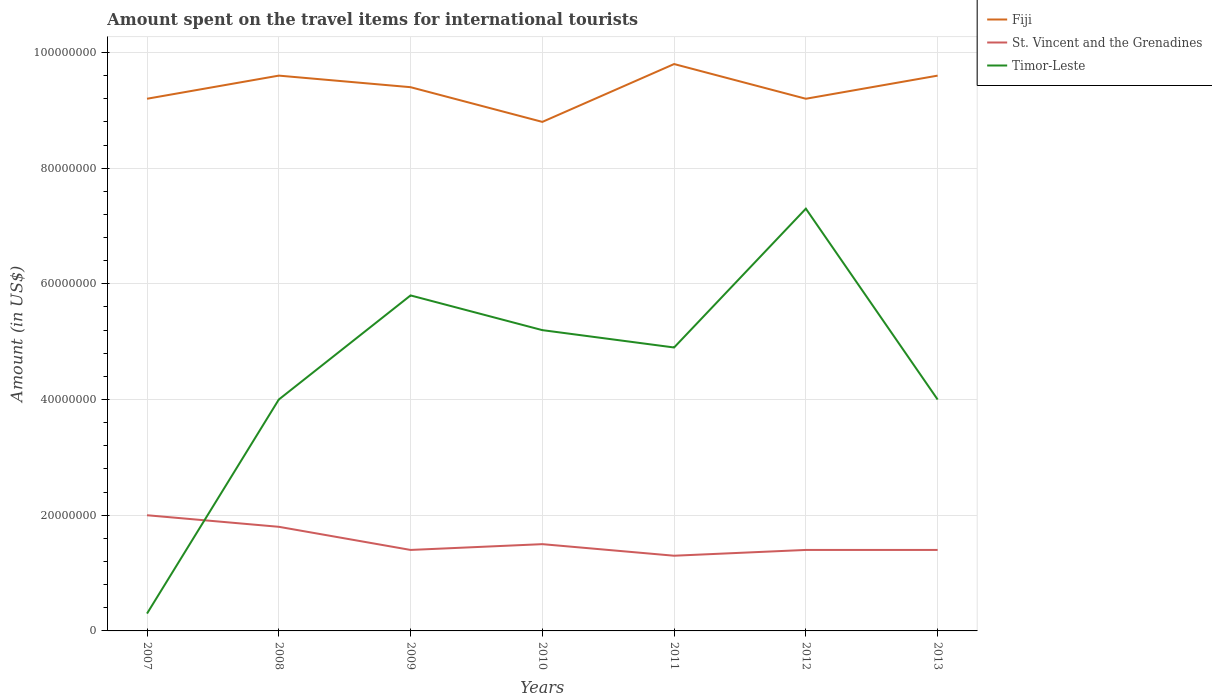How many different coloured lines are there?
Provide a succinct answer. 3. Across all years, what is the maximum amount spent on the travel items for international tourists in St. Vincent and the Grenadines?
Provide a short and direct response. 1.30e+07. In which year was the amount spent on the travel items for international tourists in Fiji maximum?
Ensure brevity in your answer.  2010. What is the difference between the highest and the second highest amount spent on the travel items for international tourists in St. Vincent and the Grenadines?
Offer a very short reply. 7.00e+06. Is the amount spent on the travel items for international tourists in Fiji strictly greater than the amount spent on the travel items for international tourists in St. Vincent and the Grenadines over the years?
Provide a short and direct response. No. How many years are there in the graph?
Your response must be concise. 7. Are the values on the major ticks of Y-axis written in scientific E-notation?
Your response must be concise. No. Does the graph contain any zero values?
Your response must be concise. No. Does the graph contain grids?
Offer a terse response. Yes. How are the legend labels stacked?
Give a very brief answer. Vertical. What is the title of the graph?
Provide a succinct answer. Amount spent on the travel items for international tourists. What is the label or title of the X-axis?
Your answer should be very brief. Years. What is the label or title of the Y-axis?
Your answer should be very brief. Amount (in US$). What is the Amount (in US$) of Fiji in 2007?
Give a very brief answer. 9.20e+07. What is the Amount (in US$) of St. Vincent and the Grenadines in 2007?
Offer a terse response. 2.00e+07. What is the Amount (in US$) of Fiji in 2008?
Keep it short and to the point. 9.60e+07. What is the Amount (in US$) in St. Vincent and the Grenadines in 2008?
Make the answer very short. 1.80e+07. What is the Amount (in US$) in Timor-Leste in 2008?
Offer a very short reply. 4.00e+07. What is the Amount (in US$) of Fiji in 2009?
Provide a short and direct response. 9.40e+07. What is the Amount (in US$) in St. Vincent and the Grenadines in 2009?
Provide a short and direct response. 1.40e+07. What is the Amount (in US$) in Timor-Leste in 2009?
Keep it short and to the point. 5.80e+07. What is the Amount (in US$) of Fiji in 2010?
Keep it short and to the point. 8.80e+07. What is the Amount (in US$) of St. Vincent and the Grenadines in 2010?
Your response must be concise. 1.50e+07. What is the Amount (in US$) in Timor-Leste in 2010?
Provide a short and direct response. 5.20e+07. What is the Amount (in US$) in Fiji in 2011?
Your response must be concise. 9.80e+07. What is the Amount (in US$) of St. Vincent and the Grenadines in 2011?
Provide a short and direct response. 1.30e+07. What is the Amount (in US$) in Timor-Leste in 2011?
Ensure brevity in your answer.  4.90e+07. What is the Amount (in US$) in Fiji in 2012?
Keep it short and to the point. 9.20e+07. What is the Amount (in US$) of St. Vincent and the Grenadines in 2012?
Your response must be concise. 1.40e+07. What is the Amount (in US$) of Timor-Leste in 2012?
Make the answer very short. 7.30e+07. What is the Amount (in US$) of Fiji in 2013?
Give a very brief answer. 9.60e+07. What is the Amount (in US$) in St. Vincent and the Grenadines in 2013?
Your answer should be compact. 1.40e+07. What is the Amount (in US$) of Timor-Leste in 2013?
Provide a succinct answer. 4.00e+07. Across all years, what is the maximum Amount (in US$) of Fiji?
Your response must be concise. 9.80e+07. Across all years, what is the maximum Amount (in US$) of Timor-Leste?
Your answer should be very brief. 7.30e+07. Across all years, what is the minimum Amount (in US$) in Fiji?
Provide a succinct answer. 8.80e+07. Across all years, what is the minimum Amount (in US$) of St. Vincent and the Grenadines?
Ensure brevity in your answer.  1.30e+07. Across all years, what is the minimum Amount (in US$) in Timor-Leste?
Offer a very short reply. 3.00e+06. What is the total Amount (in US$) of Fiji in the graph?
Keep it short and to the point. 6.56e+08. What is the total Amount (in US$) of St. Vincent and the Grenadines in the graph?
Give a very brief answer. 1.08e+08. What is the total Amount (in US$) in Timor-Leste in the graph?
Your response must be concise. 3.15e+08. What is the difference between the Amount (in US$) of Timor-Leste in 2007 and that in 2008?
Provide a short and direct response. -3.70e+07. What is the difference between the Amount (in US$) of Fiji in 2007 and that in 2009?
Ensure brevity in your answer.  -2.00e+06. What is the difference between the Amount (in US$) of St. Vincent and the Grenadines in 2007 and that in 2009?
Give a very brief answer. 6.00e+06. What is the difference between the Amount (in US$) in Timor-Leste in 2007 and that in 2009?
Your answer should be compact. -5.50e+07. What is the difference between the Amount (in US$) in Timor-Leste in 2007 and that in 2010?
Offer a terse response. -4.90e+07. What is the difference between the Amount (in US$) in Fiji in 2007 and that in 2011?
Ensure brevity in your answer.  -6.00e+06. What is the difference between the Amount (in US$) of St. Vincent and the Grenadines in 2007 and that in 2011?
Provide a succinct answer. 7.00e+06. What is the difference between the Amount (in US$) in Timor-Leste in 2007 and that in 2011?
Ensure brevity in your answer.  -4.60e+07. What is the difference between the Amount (in US$) of Fiji in 2007 and that in 2012?
Your answer should be compact. 0. What is the difference between the Amount (in US$) of St. Vincent and the Grenadines in 2007 and that in 2012?
Provide a short and direct response. 6.00e+06. What is the difference between the Amount (in US$) in Timor-Leste in 2007 and that in 2012?
Your answer should be compact. -7.00e+07. What is the difference between the Amount (in US$) of Timor-Leste in 2007 and that in 2013?
Ensure brevity in your answer.  -3.70e+07. What is the difference between the Amount (in US$) of Fiji in 2008 and that in 2009?
Provide a short and direct response. 2.00e+06. What is the difference between the Amount (in US$) of St. Vincent and the Grenadines in 2008 and that in 2009?
Make the answer very short. 4.00e+06. What is the difference between the Amount (in US$) in Timor-Leste in 2008 and that in 2009?
Provide a short and direct response. -1.80e+07. What is the difference between the Amount (in US$) in Fiji in 2008 and that in 2010?
Offer a very short reply. 8.00e+06. What is the difference between the Amount (in US$) in Timor-Leste in 2008 and that in 2010?
Your answer should be very brief. -1.20e+07. What is the difference between the Amount (in US$) of St. Vincent and the Grenadines in 2008 and that in 2011?
Provide a short and direct response. 5.00e+06. What is the difference between the Amount (in US$) in Timor-Leste in 2008 and that in 2011?
Your answer should be compact. -9.00e+06. What is the difference between the Amount (in US$) in Timor-Leste in 2008 and that in 2012?
Your answer should be very brief. -3.30e+07. What is the difference between the Amount (in US$) in Fiji in 2009 and that in 2010?
Provide a short and direct response. 6.00e+06. What is the difference between the Amount (in US$) in St. Vincent and the Grenadines in 2009 and that in 2010?
Ensure brevity in your answer.  -1.00e+06. What is the difference between the Amount (in US$) in St. Vincent and the Grenadines in 2009 and that in 2011?
Provide a succinct answer. 1.00e+06. What is the difference between the Amount (in US$) of Timor-Leste in 2009 and that in 2011?
Make the answer very short. 9.00e+06. What is the difference between the Amount (in US$) in Fiji in 2009 and that in 2012?
Your response must be concise. 2.00e+06. What is the difference between the Amount (in US$) in Timor-Leste in 2009 and that in 2012?
Your response must be concise. -1.50e+07. What is the difference between the Amount (in US$) of Fiji in 2009 and that in 2013?
Offer a very short reply. -2.00e+06. What is the difference between the Amount (in US$) of St. Vincent and the Grenadines in 2009 and that in 2013?
Make the answer very short. 0. What is the difference between the Amount (in US$) of Timor-Leste in 2009 and that in 2013?
Your answer should be very brief. 1.80e+07. What is the difference between the Amount (in US$) in Fiji in 2010 and that in 2011?
Offer a very short reply. -1.00e+07. What is the difference between the Amount (in US$) of St. Vincent and the Grenadines in 2010 and that in 2011?
Keep it short and to the point. 2.00e+06. What is the difference between the Amount (in US$) in St. Vincent and the Grenadines in 2010 and that in 2012?
Give a very brief answer. 1.00e+06. What is the difference between the Amount (in US$) in Timor-Leste in 2010 and that in 2012?
Keep it short and to the point. -2.10e+07. What is the difference between the Amount (in US$) in Fiji in 2010 and that in 2013?
Make the answer very short. -8.00e+06. What is the difference between the Amount (in US$) of St. Vincent and the Grenadines in 2010 and that in 2013?
Offer a very short reply. 1.00e+06. What is the difference between the Amount (in US$) in Timor-Leste in 2011 and that in 2012?
Make the answer very short. -2.40e+07. What is the difference between the Amount (in US$) in Timor-Leste in 2011 and that in 2013?
Ensure brevity in your answer.  9.00e+06. What is the difference between the Amount (in US$) of St. Vincent and the Grenadines in 2012 and that in 2013?
Keep it short and to the point. 0. What is the difference between the Amount (in US$) in Timor-Leste in 2012 and that in 2013?
Ensure brevity in your answer.  3.30e+07. What is the difference between the Amount (in US$) of Fiji in 2007 and the Amount (in US$) of St. Vincent and the Grenadines in 2008?
Your response must be concise. 7.40e+07. What is the difference between the Amount (in US$) in Fiji in 2007 and the Amount (in US$) in Timor-Leste in 2008?
Your answer should be very brief. 5.20e+07. What is the difference between the Amount (in US$) of St. Vincent and the Grenadines in 2007 and the Amount (in US$) of Timor-Leste in 2008?
Ensure brevity in your answer.  -2.00e+07. What is the difference between the Amount (in US$) in Fiji in 2007 and the Amount (in US$) in St. Vincent and the Grenadines in 2009?
Your answer should be compact. 7.80e+07. What is the difference between the Amount (in US$) in Fiji in 2007 and the Amount (in US$) in Timor-Leste in 2009?
Offer a very short reply. 3.40e+07. What is the difference between the Amount (in US$) of St. Vincent and the Grenadines in 2007 and the Amount (in US$) of Timor-Leste in 2009?
Provide a short and direct response. -3.80e+07. What is the difference between the Amount (in US$) in Fiji in 2007 and the Amount (in US$) in St. Vincent and the Grenadines in 2010?
Make the answer very short. 7.70e+07. What is the difference between the Amount (in US$) in Fiji in 2007 and the Amount (in US$) in Timor-Leste in 2010?
Make the answer very short. 4.00e+07. What is the difference between the Amount (in US$) of St. Vincent and the Grenadines in 2007 and the Amount (in US$) of Timor-Leste in 2010?
Offer a very short reply. -3.20e+07. What is the difference between the Amount (in US$) of Fiji in 2007 and the Amount (in US$) of St. Vincent and the Grenadines in 2011?
Your answer should be compact. 7.90e+07. What is the difference between the Amount (in US$) of Fiji in 2007 and the Amount (in US$) of Timor-Leste in 2011?
Ensure brevity in your answer.  4.30e+07. What is the difference between the Amount (in US$) of St. Vincent and the Grenadines in 2007 and the Amount (in US$) of Timor-Leste in 2011?
Make the answer very short. -2.90e+07. What is the difference between the Amount (in US$) in Fiji in 2007 and the Amount (in US$) in St. Vincent and the Grenadines in 2012?
Your response must be concise. 7.80e+07. What is the difference between the Amount (in US$) in Fiji in 2007 and the Amount (in US$) in Timor-Leste in 2012?
Keep it short and to the point. 1.90e+07. What is the difference between the Amount (in US$) in St. Vincent and the Grenadines in 2007 and the Amount (in US$) in Timor-Leste in 2012?
Keep it short and to the point. -5.30e+07. What is the difference between the Amount (in US$) in Fiji in 2007 and the Amount (in US$) in St. Vincent and the Grenadines in 2013?
Provide a short and direct response. 7.80e+07. What is the difference between the Amount (in US$) of Fiji in 2007 and the Amount (in US$) of Timor-Leste in 2013?
Provide a succinct answer. 5.20e+07. What is the difference between the Amount (in US$) in St. Vincent and the Grenadines in 2007 and the Amount (in US$) in Timor-Leste in 2013?
Your response must be concise. -2.00e+07. What is the difference between the Amount (in US$) in Fiji in 2008 and the Amount (in US$) in St. Vincent and the Grenadines in 2009?
Your answer should be compact. 8.20e+07. What is the difference between the Amount (in US$) of Fiji in 2008 and the Amount (in US$) of Timor-Leste in 2009?
Ensure brevity in your answer.  3.80e+07. What is the difference between the Amount (in US$) of St. Vincent and the Grenadines in 2008 and the Amount (in US$) of Timor-Leste in 2009?
Give a very brief answer. -4.00e+07. What is the difference between the Amount (in US$) in Fiji in 2008 and the Amount (in US$) in St. Vincent and the Grenadines in 2010?
Your response must be concise. 8.10e+07. What is the difference between the Amount (in US$) of Fiji in 2008 and the Amount (in US$) of Timor-Leste in 2010?
Your answer should be very brief. 4.40e+07. What is the difference between the Amount (in US$) of St. Vincent and the Grenadines in 2008 and the Amount (in US$) of Timor-Leste in 2010?
Offer a very short reply. -3.40e+07. What is the difference between the Amount (in US$) in Fiji in 2008 and the Amount (in US$) in St. Vincent and the Grenadines in 2011?
Offer a terse response. 8.30e+07. What is the difference between the Amount (in US$) of Fiji in 2008 and the Amount (in US$) of Timor-Leste in 2011?
Provide a short and direct response. 4.70e+07. What is the difference between the Amount (in US$) of St. Vincent and the Grenadines in 2008 and the Amount (in US$) of Timor-Leste in 2011?
Offer a very short reply. -3.10e+07. What is the difference between the Amount (in US$) of Fiji in 2008 and the Amount (in US$) of St. Vincent and the Grenadines in 2012?
Make the answer very short. 8.20e+07. What is the difference between the Amount (in US$) in Fiji in 2008 and the Amount (in US$) in Timor-Leste in 2012?
Your answer should be compact. 2.30e+07. What is the difference between the Amount (in US$) of St. Vincent and the Grenadines in 2008 and the Amount (in US$) of Timor-Leste in 2012?
Offer a very short reply. -5.50e+07. What is the difference between the Amount (in US$) of Fiji in 2008 and the Amount (in US$) of St. Vincent and the Grenadines in 2013?
Offer a terse response. 8.20e+07. What is the difference between the Amount (in US$) of Fiji in 2008 and the Amount (in US$) of Timor-Leste in 2013?
Ensure brevity in your answer.  5.60e+07. What is the difference between the Amount (in US$) in St. Vincent and the Grenadines in 2008 and the Amount (in US$) in Timor-Leste in 2013?
Keep it short and to the point. -2.20e+07. What is the difference between the Amount (in US$) of Fiji in 2009 and the Amount (in US$) of St. Vincent and the Grenadines in 2010?
Your answer should be very brief. 7.90e+07. What is the difference between the Amount (in US$) in Fiji in 2009 and the Amount (in US$) in Timor-Leste in 2010?
Make the answer very short. 4.20e+07. What is the difference between the Amount (in US$) in St. Vincent and the Grenadines in 2009 and the Amount (in US$) in Timor-Leste in 2010?
Ensure brevity in your answer.  -3.80e+07. What is the difference between the Amount (in US$) in Fiji in 2009 and the Amount (in US$) in St. Vincent and the Grenadines in 2011?
Offer a very short reply. 8.10e+07. What is the difference between the Amount (in US$) of Fiji in 2009 and the Amount (in US$) of Timor-Leste in 2011?
Your answer should be very brief. 4.50e+07. What is the difference between the Amount (in US$) in St. Vincent and the Grenadines in 2009 and the Amount (in US$) in Timor-Leste in 2011?
Provide a succinct answer. -3.50e+07. What is the difference between the Amount (in US$) in Fiji in 2009 and the Amount (in US$) in St. Vincent and the Grenadines in 2012?
Provide a short and direct response. 8.00e+07. What is the difference between the Amount (in US$) of Fiji in 2009 and the Amount (in US$) of Timor-Leste in 2012?
Your answer should be compact. 2.10e+07. What is the difference between the Amount (in US$) in St. Vincent and the Grenadines in 2009 and the Amount (in US$) in Timor-Leste in 2012?
Give a very brief answer. -5.90e+07. What is the difference between the Amount (in US$) in Fiji in 2009 and the Amount (in US$) in St. Vincent and the Grenadines in 2013?
Your response must be concise. 8.00e+07. What is the difference between the Amount (in US$) of Fiji in 2009 and the Amount (in US$) of Timor-Leste in 2013?
Give a very brief answer. 5.40e+07. What is the difference between the Amount (in US$) in St. Vincent and the Grenadines in 2009 and the Amount (in US$) in Timor-Leste in 2013?
Your answer should be compact. -2.60e+07. What is the difference between the Amount (in US$) in Fiji in 2010 and the Amount (in US$) in St. Vincent and the Grenadines in 2011?
Provide a short and direct response. 7.50e+07. What is the difference between the Amount (in US$) in Fiji in 2010 and the Amount (in US$) in Timor-Leste in 2011?
Provide a succinct answer. 3.90e+07. What is the difference between the Amount (in US$) of St. Vincent and the Grenadines in 2010 and the Amount (in US$) of Timor-Leste in 2011?
Your answer should be very brief. -3.40e+07. What is the difference between the Amount (in US$) in Fiji in 2010 and the Amount (in US$) in St. Vincent and the Grenadines in 2012?
Ensure brevity in your answer.  7.40e+07. What is the difference between the Amount (in US$) of Fiji in 2010 and the Amount (in US$) of Timor-Leste in 2012?
Provide a short and direct response. 1.50e+07. What is the difference between the Amount (in US$) of St. Vincent and the Grenadines in 2010 and the Amount (in US$) of Timor-Leste in 2012?
Your response must be concise. -5.80e+07. What is the difference between the Amount (in US$) of Fiji in 2010 and the Amount (in US$) of St. Vincent and the Grenadines in 2013?
Make the answer very short. 7.40e+07. What is the difference between the Amount (in US$) of Fiji in 2010 and the Amount (in US$) of Timor-Leste in 2013?
Keep it short and to the point. 4.80e+07. What is the difference between the Amount (in US$) in St. Vincent and the Grenadines in 2010 and the Amount (in US$) in Timor-Leste in 2013?
Make the answer very short. -2.50e+07. What is the difference between the Amount (in US$) in Fiji in 2011 and the Amount (in US$) in St. Vincent and the Grenadines in 2012?
Keep it short and to the point. 8.40e+07. What is the difference between the Amount (in US$) of Fiji in 2011 and the Amount (in US$) of Timor-Leste in 2012?
Make the answer very short. 2.50e+07. What is the difference between the Amount (in US$) of St. Vincent and the Grenadines in 2011 and the Amount (in US$) of Timor-Leste in 2012?
Offer a terse response. -6.00e+07. What is the difference between the Amount (in US$) of Fiji in 2011 and the Amount (in US$) of St. Vincent and the Grenadines in 2013?
Offer a terse response. 8.40e+07. What is the difference between the Amount (in US$) in Fiji in 2011 and the Amount (in US$) in Timor-Leste in 2013?
Provide a succinct answer. 5.80e+07. What is the difference between the Amount (in US$) of St. Vincent and the Grenadines in 2011 and the Amount (in US$) of Timor-Leste in 2013?
Offer a very short reply. -2.70e+07. What is the difference between the Amount (in US$) of Fiji in 2012 and the Amount (in US$) of St. Vincent and the Grenadines in 2013?
Provide a succinct answer. 7.80e+07. What is the difference between the Amount (in US$) of Fiji in 2012 and the Amount (in US$) of Timor-Leste in 2013?
Offer a terse response. 5.20e+07. What is the difference between the Amount (in US$) in St. Vincent and the Grenadines in 2012 and the Amount (in US$) in Timor-Leste in 2013?
Offer a very short reply. -2.60e+07. What is the average Amount (in US$) in Fiji per year?
Provide a short and direct response. 9.37e+07. What is the average Amount (in US$) in St. Vincent and the Grenadines per year?
Offer a terse response. 1.54e+07. What is the average Amount (in US$) in Timor-Leste per year?
Offer a terse response. 4.50e+07. In the year 2007, what is the difference between the Amount (in US$) of Fiji and Amount (in US$) of St. Vincent and the Grenadines?
Your answer should be very brief. 7.20e+07. In the year 2007, what is the difference between the Amount (in US$) of Fiji and Amount (in US$) of Timor-Leste?
Make the answer very short. 8.90e+07. In the year 2007, what is the difference between the Amount (in US$) in St. Vincent and the Grenadines and Amount (in US$) in Timor-Leste?
Ensure brevity in your answer.  1.70e+07. In the year 2008, what is the difference between the Amount (in US$) in Fiji and Amount (in US$) in St. Vincent and the Grenadines?
Give a very brief answer. 7.80e+07. In the year 2008, what is the difference between the Amount (in US$) in Fiji and Amount (in US$) in Timor-Leste?
Your answer should be very brief. 5.60e+07. In the year 2008, what is the difference between the Amount (in US$) of St. Vincent and the Grenadines and Amount (in US$) of Timor-Leste?
Provide a short and direct response. -2.20e+07. In the year 2009, what is the difference between the Amount (in US$) of Fiji and Amount (in US$) of St. Vincent and the Grenadines?
Offer a very short reply. 8.00e+07. In the year 2009, what is the difference between the Amount (in US$) of Fiji and Amount (in US$) of Timor-Leste?
Your response must be concise. 3.60e+07. In the year 2009, what is the difference between the Amount (in US$) in St. Vincent and the Grenadines and Amount (in US$) in Timor-Leste?
Offer a terse response. -4.40e+07. In the year 2010, what is the difference between the Amount (in US$) in Fiji and Amount (in US$) in St. Vincent and the Grenadines?
Make the answer very short. 7.30e+07. In the year 2010, what is the difference between the Amount (in US$) in Fiji and Amount (in US$) in Timor-Leste?
Ensure brevity in your answer.  3.60e+07. In the year 2010, what is the difference between the Amount (in US$) of St. Vincent and the Grenadines and Amount (in US$) of Timor-Leste?
Ensure brevity in your answer.  -3.70e+07. In the year 2011, what is the difference between the Amount (in US$) of Fiji and Amount (in US$) of St. Vincent and the Grenadines?
Make the answer very short. 8.50e+07. In the year 2011, what is the difference between the Amount (in US$) of Fiji and Amount (in US$) of Timor-Leste?
Provide a short and direct response. 4.90e+07. In the year 2011, what is the difference between the Amount (in US$) of St. Vincent and the Grenadines and Amount (in US$) of Timor-Leste?
Ensure brevity in your answer.  -3.60e+07. In the year 2012, what is the difference between the Amount (in US$) in Fiji and Amount (in US$) in St. Vincent and the Grenadines?
Offer a terse response. 7.80e+07. In the year 2012, what is the difference between the Amount (in US$) of Fiji and Amount (in US$) of Timor-Leste?
Offer a very short reply. 1.90e+07. In the year 2012, what is the difference between the Amount (in US$) in St. Vincent and the Grenadines and Amount (in US$) in Timor-Leste?
Provide a short and direct response. -5.90e+07. In the year 2013, what is the difference between the Amount (in US$) in Fiji and Amount (in US$) in St. Vincent and the Grenadines?
Keep it short and to the point. 8.20e+07. In the year 2013, what is the difference between the Amount (in US$) in Fiji and Amount (in US$) in Timor-Leste?
Offer a terse response. 5.60e+07. In the year 2013, what is the difference between the Amount (in US$) of St. Vincent and the Grenadines and Amount (in US$) of Timor-Leste?
Make the answer very short. -2.60e+07. What is the ratio of the Amount (in US$) of Timor-Leste in 2007 to that in 2008?
Provide a short and direct response. 0.07. What is the ratio of the Amount (in US$) in Fiji in 2007 to that in 2009?
Your answer should be compact. 0.98. What is the ratio of the Amount (in US$) in St. Vincent and the Grenadines in 2007 to that in 2009?
Provide a succinct answer. 1.43. What is the ratio of the Amount (in US$) in Timor-Leste in 2007 to that in 2009?
Your answer should be very brief. 0.05. What is the ratio of the Amount (in US$) of Fiji in 2007 to that in 2010?
Provide a short and direct response. 1.05. What is the ratio of the Amount (in US$) in St. Vincent and the Grenadines in 2007 to that in 2010?
Offer a terse response. 1.33. What is the ratio of the Amount (in US$) of Timor-Leste in 2007 to that in 2010?
Your answer should be very brief. 0.06. What is the ratio of the Amount (in US$) in Fiji in 2007 to that in 2011?
Your response must be concise. 0.94. What is the ratio of the Amount (in US$) of St. Vincent and the Grenadines in 2007 to that in 2011?
Your response must be concise. 1.54. What is the ratio of the Amount (in US$) in Timor-Leste in 2007 to that in 2011?
Your answer should be compact. 0.06. What is the ratio of the Amount (in US$) in Fiji in 2007 to that in 2012?
Your answer should be compact. 1. What is the ratio of the Amount (in US$) of St. Vincent and the Grenadines in 2007 to that in 2012?
Provide a succinct answer. 1.43. What is the ratio of the Amount (in US$) of Timor-Leste in 2007 to that in 2012?
Your answer should be compact. 0.04. What is the ratio of the Amount (in US$) in St. Vincent and the Grenadines in 2007 to that in 2013?
Ensure brevity in your answer.  1.43. What is the ratio of the Amount (in US$) in Timor-Leste in 2007 to that in 2013?
Keep it short and to the point. 0.07. What is the ratio of the Amount (in US$) of Fiji in 2008 to that in 2009?
Keep it short and to the point. 1.02. What is the ratio of the Amount (in US$) of St. Vincent and the Grenadines in 2008 to that in 2009?
Give a very brief answer. 1.29. What is the ratio of the Amount (in US$) in Timor-Leste in 2008 to that in 2009?
Ensure brevity in your answer.  0.69. What is the ratio of the Amount (in US$) of St. Vincent and the Grenadines in 2008 to that in 2010?
Ensure brevity in your answer.  1.2. What is the ratio of the Amount (in US$) in Timor-Leste in 2008 to that in 2010?
Keep it short and to the point. 0.77. What is the ratio of the Amount (in US$) of Fiji in 2008 to that in 2011?
Your answer should be compact. 0.98. What is the ratio of the Amount (in US$) in St. Vincent and the Grenadines in 2008 to that in 2011?
Your answer should be compact. 1.38. What is the ratio of the Amount (in US$) of Timor-Leste in 2008 to that in 2011?
Offer a terse response. 0.82. What is the ratio of the Amount (in US$) in Fiji in 2008 to that in 2012?
Keep it short and to the point. 1.04. What is the ratio of the Amount (in US$) of St. Vincent and the Grenadines in 2008 to that in 2012?
Offer a very short reply. 1.29. What is the ratio of the Amount (in US$) of Timor-Leste in 2008 to that in 2012?
Provide a succinct answer. 0.55. What is the ratio of the Amount (in US$) of Fiji in 2008 to that in 2013?
Make the answer very short. 1. What is the ratio of the Amount (in US$) of St. Vincent and the Grenadines in 2008 to that in 2013?
Offer a very short reply. 1.29. What is the ratio of the Amount (in US$) in Timor-Leste in 2008 to that in 2013?
Keep it short and to the point. 1. What is the ratio of the Amount (in US$) in Fiji in 2009 to that in 2010?
Your answer should be compact. 1.07. What is the ratio of the Amount (in US$) in Timor-Leste in 2009 to that in 2010?
Provide a short and direct response. 1.12. What is the ratio of the Amount (in US$) in Fiji in 2009 to that in 2011?
Offer a terse response. 0.96. What is the ratio of the Amount (in US$) in Timor-Leste in 2009 to that in 2011?
Your response must be concise. 1.18. What is the ratio of the Amount (in US$) of Fiji in 2009 to that in 2012?
Keep it short and to the point. 1.02. What is the ratio of the Amount (in US$) in Timor-Leste in 2009 to that in 2012?
Offer a terse response. 0.79. What is the ratio of the Amount (in US$) of Fiji in 2009 to that in 2013?
Keep it short and to the point. 0.98. What is the ratio of the Amount (in US$) in St. Vincent and the Grenadines in 2009 to that in 2013?
Make the answer very short. 1. What is the ratio of the Amount (in US$) in Timor-Leste in 2009 to that in 2013?
Make the answer very short. 1.45. What is the ratio of the Amount (in US$) in Fiji in 2010 to that in 2011?
Offer a very short reply. 0.9. What is the ratio of the Amount (in US$) in St. Vincent and the Grenadines in 2010 to that in 2011?
Your answer should be very brief. 1.15. What is the ratio of the Amount (in US$) of Timor-Leste in 2010 to that in 2011?
Provide a succinct answer. 1.06. What is the ratio of the Amount (in US$) of Fiji in 2010 to that in 2012?
Give a very brief answer. 0.96. What is the ratio of the Amount (in US$) of St. Vincent and the Grenadines in 2010 to that in 2012?
Offer a terse response. 1.07. What is the ratio of the Amount (in US$) in Timor-Leste in 2010 to that in 2012?
Provide a succinct answer. 0.71. What is the ratio of the Amount (in US$) of St. Vincent and the Grenadines in 2010 to that in 2013?
Offer a terse response. 1.07. What is the ratio of the Amount (in US$) in Timor-Leste in 2010 to that in 2013?
Provide a short and direct response. 1.3. What is the ratio of the Amount (in US$) of Fiji in 2011 to that in 2012?
Keep it short and to the point. 1.07. What is the ratio of the Amount (in US$) of Timor-Leste in 2011 to that in 2012?
Make the answer very short. 0.67. What is the ratio of the Amount (in US$) of Fiji in 2011 to that in 2013?
Make the answer very short. 1.02. What is the ratio of the Amount (in US$) of Timor-Leste in 2011 to that in 2013?
Make the answer very short. 1.23. What is the ratio of the Amount (in US$) in St. Vincent and the Grenadines in 2012 to that in 2013?
Offer a terse response. 1. What is the ratio of the Amount (in US$) of Timor-Leste in 2012 to that in 2013?
Provide a succinct answer. 1.82. What is the difference between the highest and the second highest Amount (in US$) in St. Vincent and the Grenadines?
Offer a terse response. 2.00e+06. What is the difference between the highest and the second highest Amount (in US$) of Timor-Leste?
Your answer should be compact. 1.50e+07. What is the difference between the highest and the lowest Amount (in US$) of Timor-Leste?
Provide a short and direct response. 7.00e+07. 